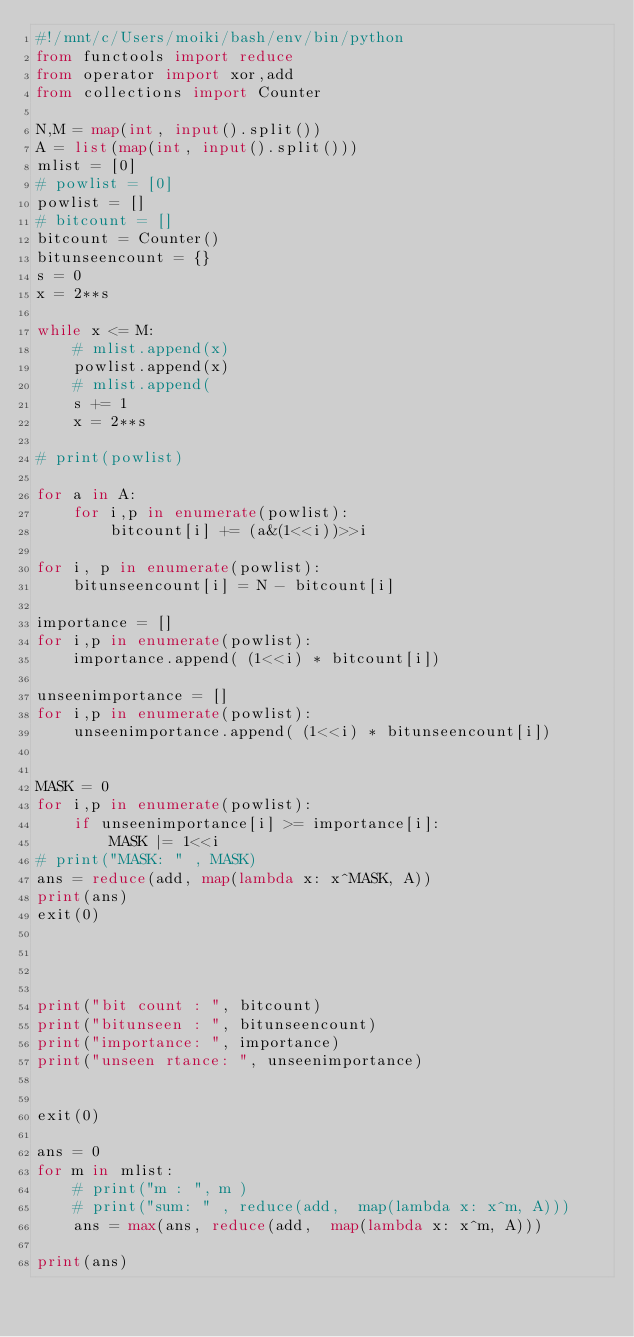<code> <loc_0><loc_0><loc_500><loc_500><_Python_>#!/mnt/c/Users/moiki/bash/env/bin/python
from functools import reduce
from operator import xor,add
from collections import Counter

N,M = map(int, input().split())
A = list(map(int, input().split()))
mlist = [0]
# powlist = [0]
powlist = []
# bitcount = []
bitcount = Counter()
bitunseencount = {}
s = 0
x = 2**s

while x <= M:
    # mlist.append(x)
    powlist.append(x)
    # mlist.append(
    s += 1
    x = 2**s

# print(powlist)

for a in A:
    for i,p in enumerate(powlist):
        bitcount[i] += (a&(1<<i))>>i

for i, p in enumerate(powlist):
    bitunseencount[i] = N - bitcount[i]

importance = []
for i,p in enumerate(powlist):
    importance.append( (1<<i) * bitcount[i])

unseenimportance = []
for i,p in enumerate(powlist):
    unseenimportance.append( (1<<i) * bitunseencount[i])


MASK = 0
for i,p in enumerate(powlist):
    if unseenimportance[i] >= importance[i]:
        MASK |= 1<<i
# print("MASK: " , MASK)
ans = reduce(add, map(lambda x: x^MASK, A))
print(ans)
exit(0)

    
   

print("bit count : ", bitcount)
print("bitunseen : ", bitunseencount)
print("importance: ", importance)
print("unseen rtance: ", unseenimportance)
        
        
exit(0)

ans = 0
for m in mlist:
    # print("m : ", m )
    # print("sum: " , reduce(add,  map(lambda x: x^m, A)))
    ans = max(ans, reduce(add,  map(lambda x: x^m, A)))

print(ans)



</code> 